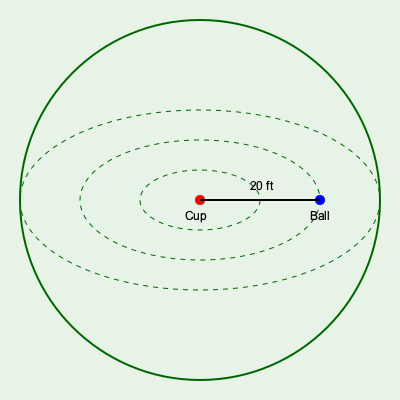On a circular green with a radius of 30 feet, a golfer's ball is located 20 feet directly to the right of the cup. The topographic lines on the green form concentric circles, with each line representing a 1-inch change in elevation. If there are three topographic lines between the ball and the cup, what is the total break (in inches) that the golfer needs to account for when putting? To solve this problem, we need to follow these steps:

1. Understand the geometry of the green:
   - The green is circular with a radius of 30 feet.
   - The ball is 20 feet directly to the right of the cup.
   - Topographic lines form concentric circles.

2. Count the number of topographic lines:
   - There are 3 topographic lines between the ball and the cup.

3. Calculate the elevation change:
   - Each topographic line represents a 1-inch change in elevation.
   - Total elevation change = Number of lines × Change per line
   - Total elevation change = 3 × 1 inch = 3 inches

4. Determine the break:
   - In this case, the total elevation change is equal to the break.
   - The break is the amount the ball will curve due to the slope.

5. Consider the direction of the break:
   - Since the topographic lines are concentric circles and the ball is to the right of the cup, the break will be from right to left.

Therefore, the total break that the golfer needs to account for is 3 inches from right to left.
Answer: 3 inches 